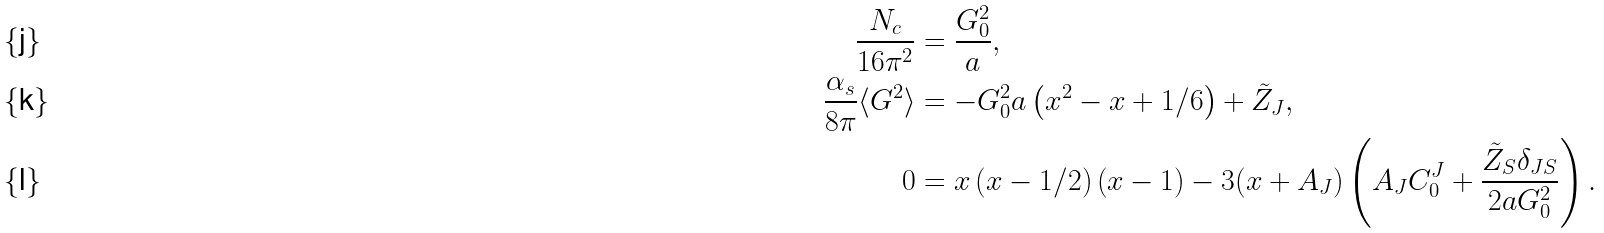<formula> <loc_0><loc_0><loc_500><loc_500>\frac { N _ { c } } { 1 6 \pi ^ { 2 } } & = \frac { G _ { 0 } ^ { 2 } } { a } , \\ \frac { \alpha _ { s } } { 8 \pi } \langle G ^ { 2 } \rangle & = - G _ { 0 } ^ { 2 } a \left ( x ^ { 2 } - x + 1 / 6 \right ) + \tilde { Z } _ { J } , \\ 0 & = x \left ( x - 1 / 2 \right ) \left ( x - 1 \right ) - 3 ( x + A _ { J } ) \left ( A _ { J } C _ { 0 } ^ { J } + \frac { \tilde { Z } _ { S } \delta _ { J S } } { 2 a G _ { 0 } ^ { 2 } } \right ) .</formula> 